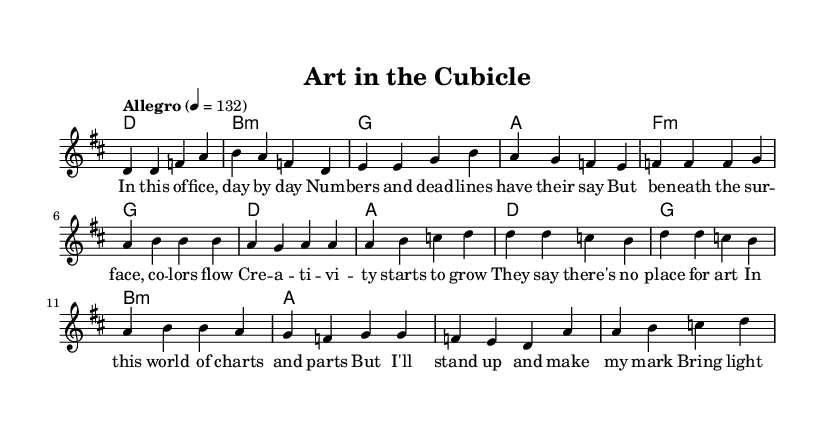What is the key signature of this music? The key signature is indicated at the beginning of the composition. It specifies D major, which has two sharps: F sharp and C sharp.
Answer: D major What is the time signature of this music? The time signature is located at the beginning, indicating how many beats are in each measure. In this case, it shows 4/4, meaning there are four beats per measure.
Answer: 4/4 What is the tempo marking for this piece? The tempo marking indicates the speed of the music and is found above the staff. Here, it indicates "Allegro" with a tempo of 132 beats per minute.
Answer: Allegro 4 = 132 How many measures are in the chorus? To find the number of measures in the chorus, we count the distinct groups of music notes in the chorus section. There are four measures that make up the chorus.
Answer: 4 What is the first lyric of the verse? The first lyric is listed under the melody for the verse section. The lyrics start with "In this of -- fice," making it clear that this is the opening line.
Answer: In this of -- fice What style of music does this sheet represent? This sheet music represents a pop-rock style, characterized by its upbeat tempo and strong melodic presence. The lyrical theme also reflects typical pop concerns about artistic expression.
Answer: Pop-rock What thematic element is expressed in the chorus? The chorus expresses the theme of standing up for artistic expression "even in this unlikely place," signifying the importance of creativity in all environments, especially unexpected ones.
Answer: Standing up for artistic expression 